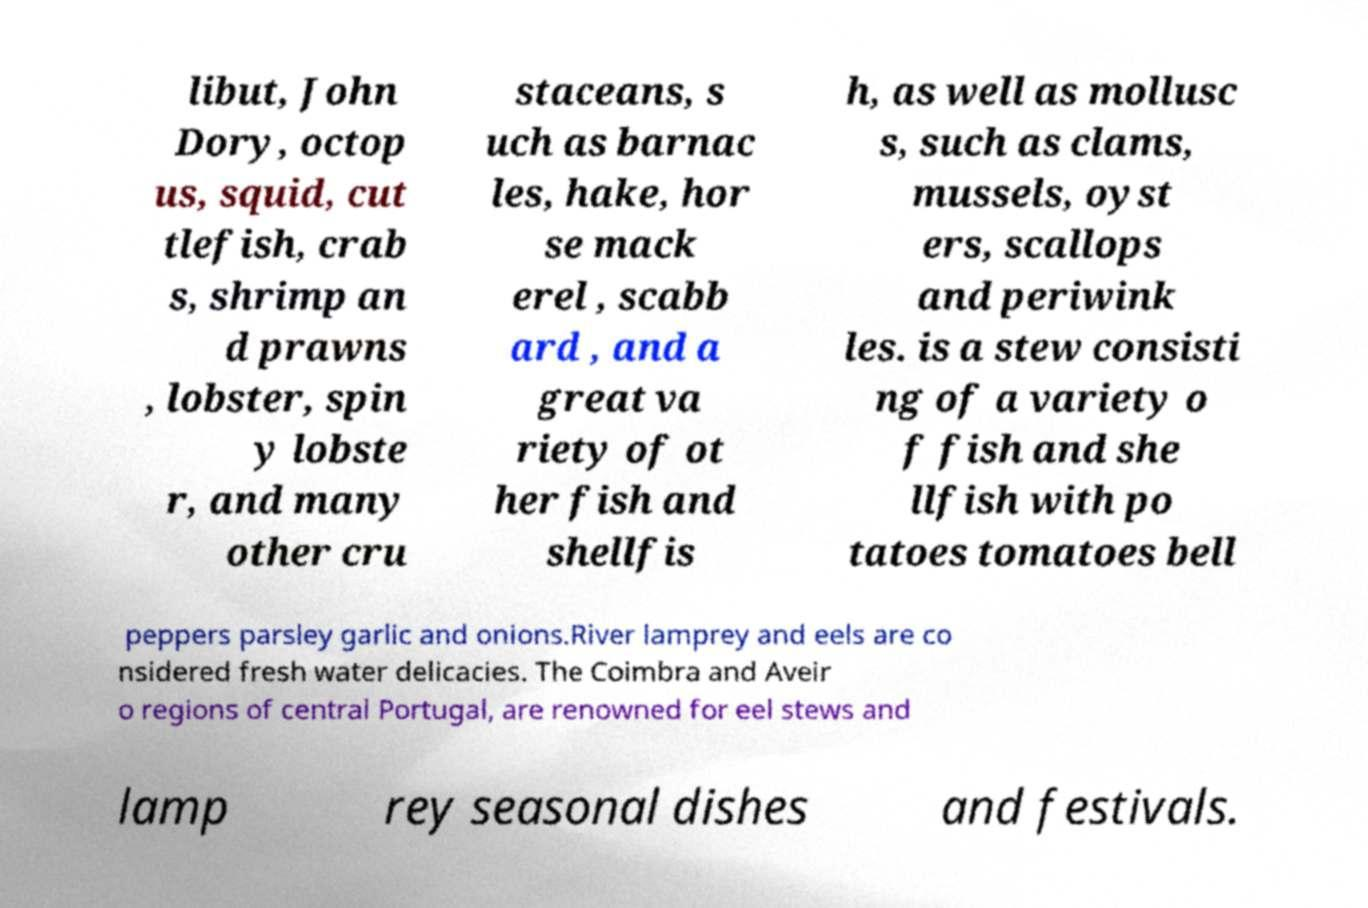Can you read and provide the text displayed in the image?This photo seems to have some interesting text. Can you extract and type it out for me? libut, John Dory, octop us, squid, cut tlefish, crab s, shrimp an d prawns , lobster, spin y lobste r, and many other cru staceans, s uch as barnac les, hake, hor se mack erel , scabb ard , and a great va riety of ot her fish and shellfis h, as well as mollusc s, such as clams, mussels, oyst ers, scallops and periwink les. is a stew consisti ng of a variety o f fish and she llfish with po tatoes tomatoes bell peppers parsley garlic and onions.River lamprey and eels are co nsidered fresh water delicacies. The Coimbra and Aveir o regions of central Portugal, are renowned for eel stews and lamp rey seasonal dishes and festivals. 